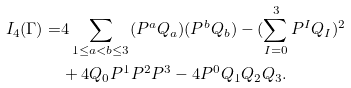Convert formula to latex. <formula><loc_0><loc_0><loc_500><loc_500>I _ { 4 } ( \Gamma ) = & 4 \sum _ { 1 \leq a < b \leq 3 } ( P ^ { a } Q _ { a } ) ( P ^ { b } Q _ { b } ) - ( \sum _ { I = 0 } ^ { 3 } P ^ { I } Q _ { I } ) ^ { 2 } \\ & + 4 Q _ { 0 } P ^ { 1 } P ^ { 2 } P ^ { 3 } - 4 P ^ { 0 } Q _ { 1 } Q _ { 2 } Q _ { 3 } .</formula> 